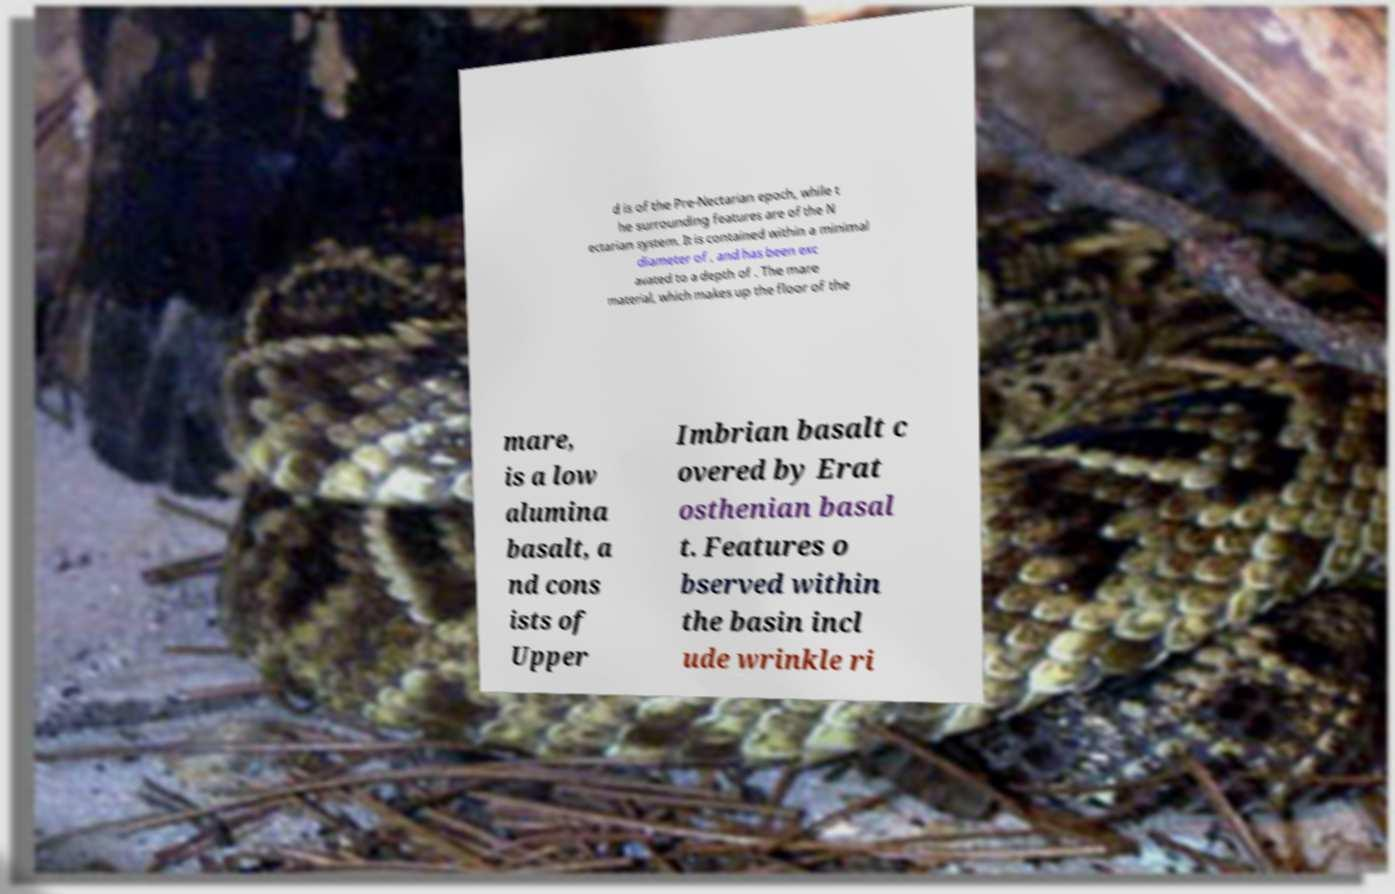Can you accurately transcribe the text from the provided image for me? d is of the Pre-Nectarian epoch, while t he surrounding features are of the N ectarian system. It is contained within a minimal diameter of , and has been exc avated to a depth of . The mare material, which makes up the floor of the mare, is a low alumina basalt, a nd cons ists of Upper Imbrian basalt c overed by Erat osthenian basal t. Features o bserved within the basin incl ude wrinkle ri 